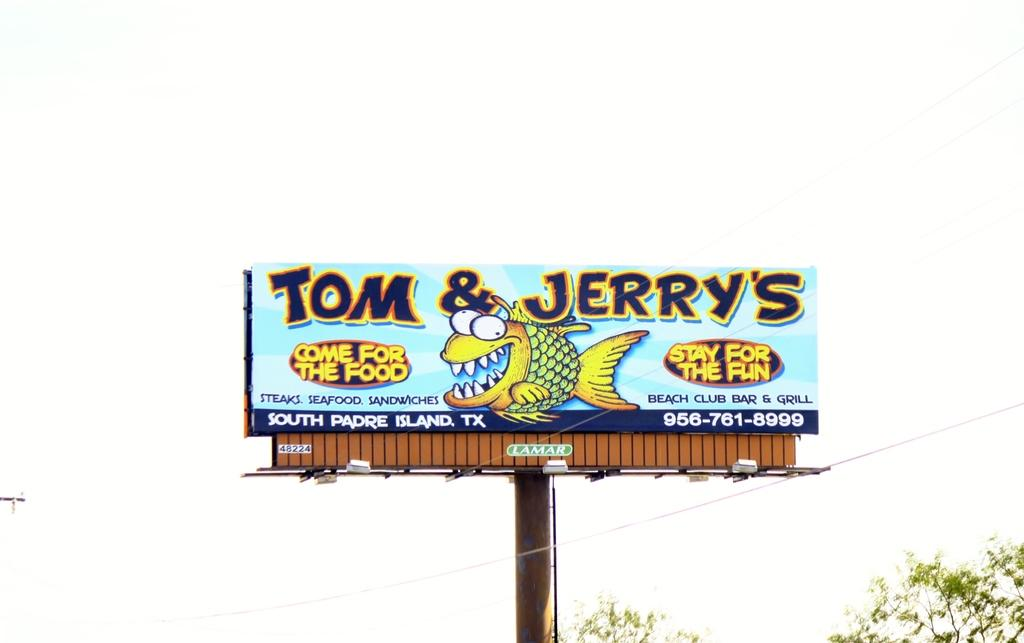<image>
Give a short and clear explanation of the subsequent image. Tom & Jerry's Beach Club and Bar is advertised on a Lamar street sign. 